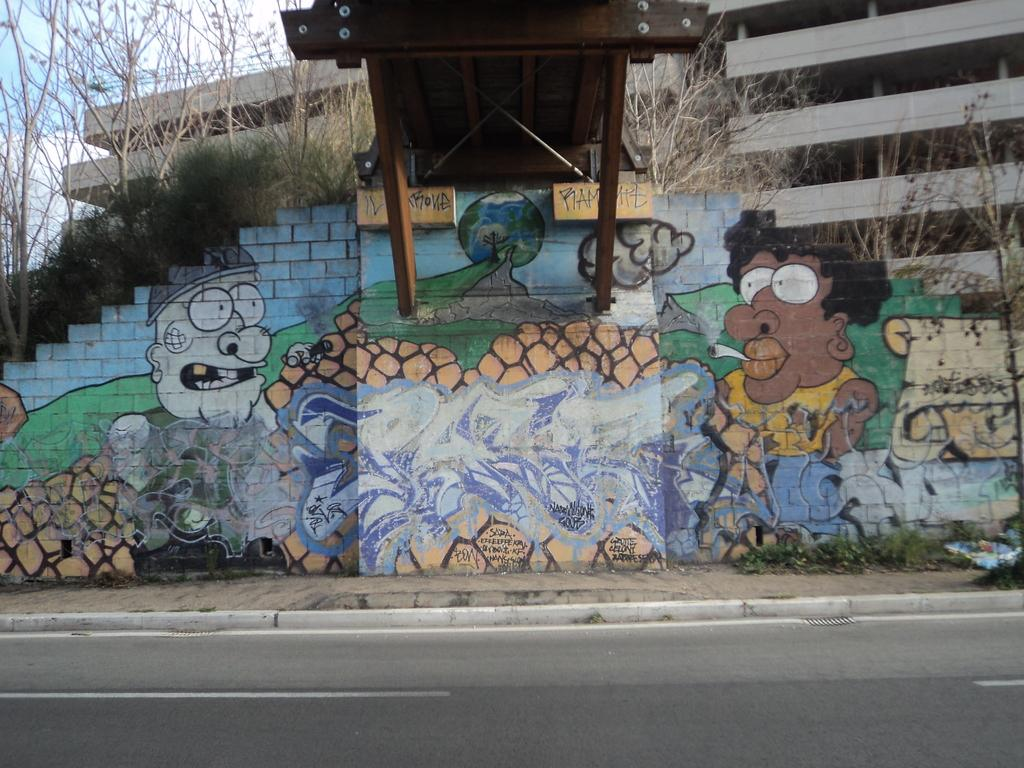What can be seen on the wall in the image? There are paintings on the wall in the image. What type of natural scenery is visible in the image? There are trees visible in the image. What type of structure is present in the image? There is a wooden bridge in the image. What type of man-made structure is present in the image? There is a building in the image. What can be seen in the background of the image? The sky is visible in the background of the image. Where is the lamp located in the image? There is no lamp present in the image. What type of dirt can be seen on the wooden bridge in the image? There is no dirt visible on the wooden bridge in the image. 